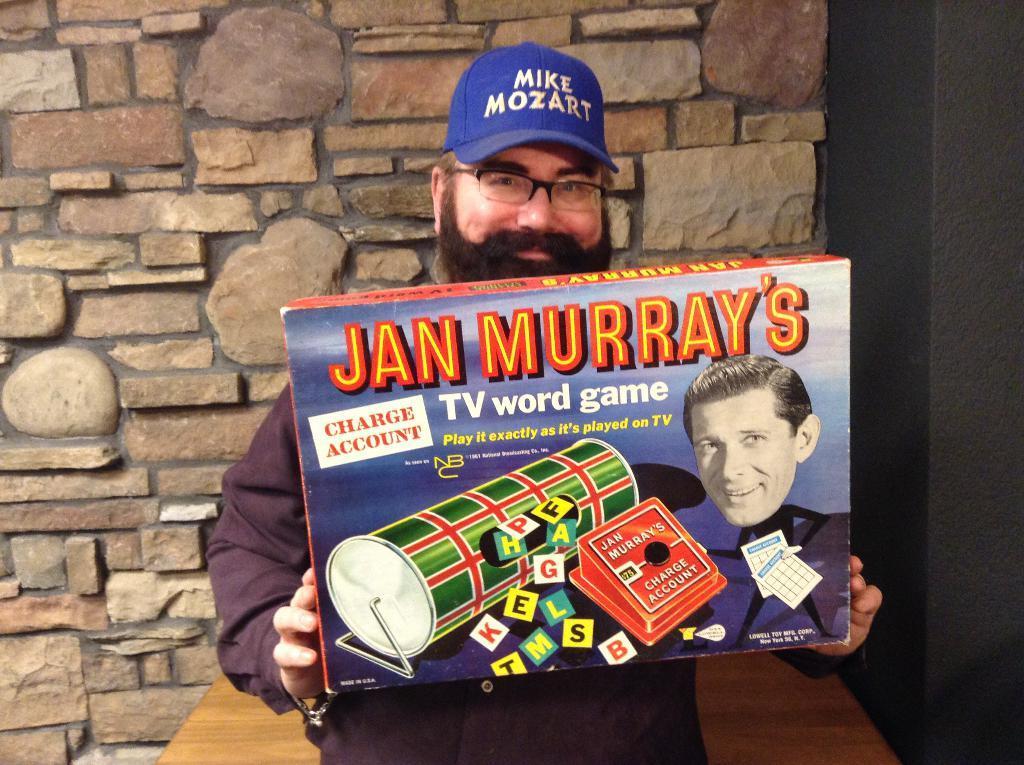In one or two sentences, can you explain what this image depicts? In the image there is a man holding a box, he is wearing blue cap and spects. Behind him there is a table in front of the wall. 